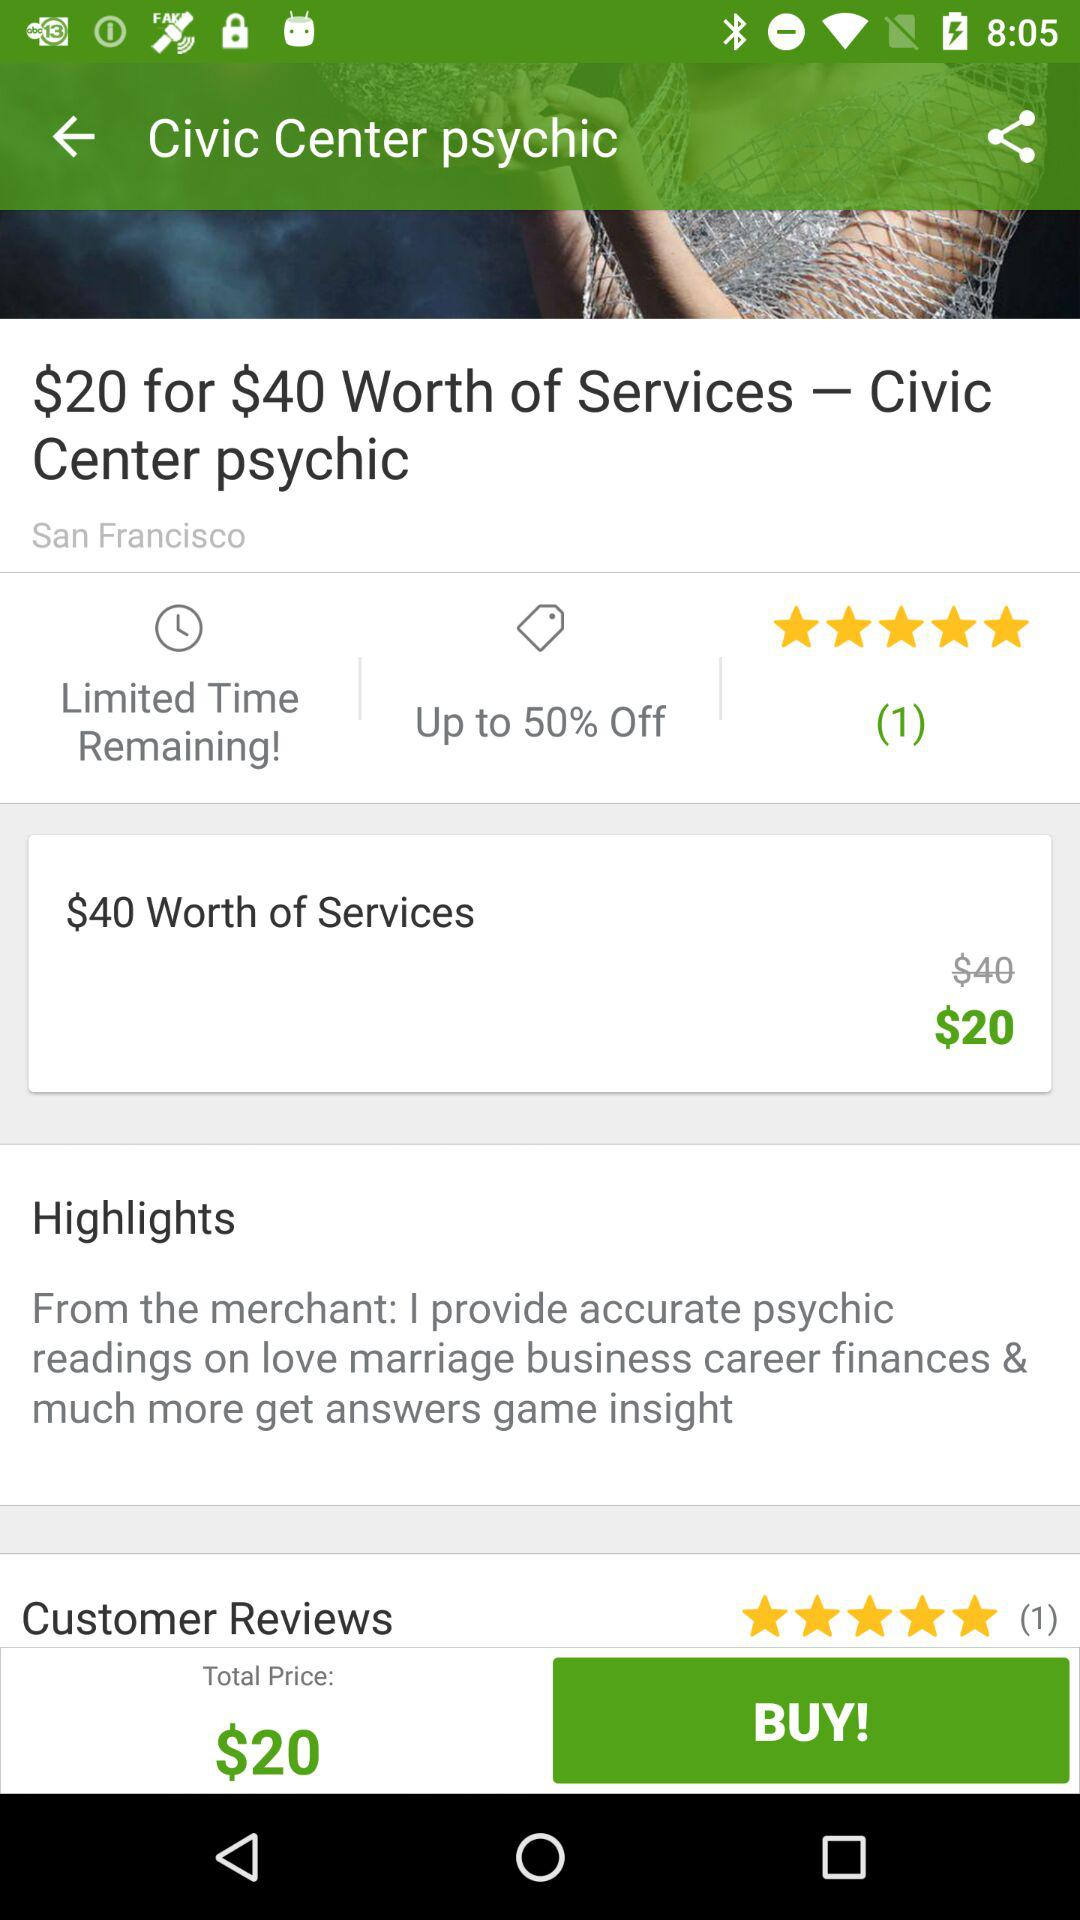What is the total price? The total price is $20. 